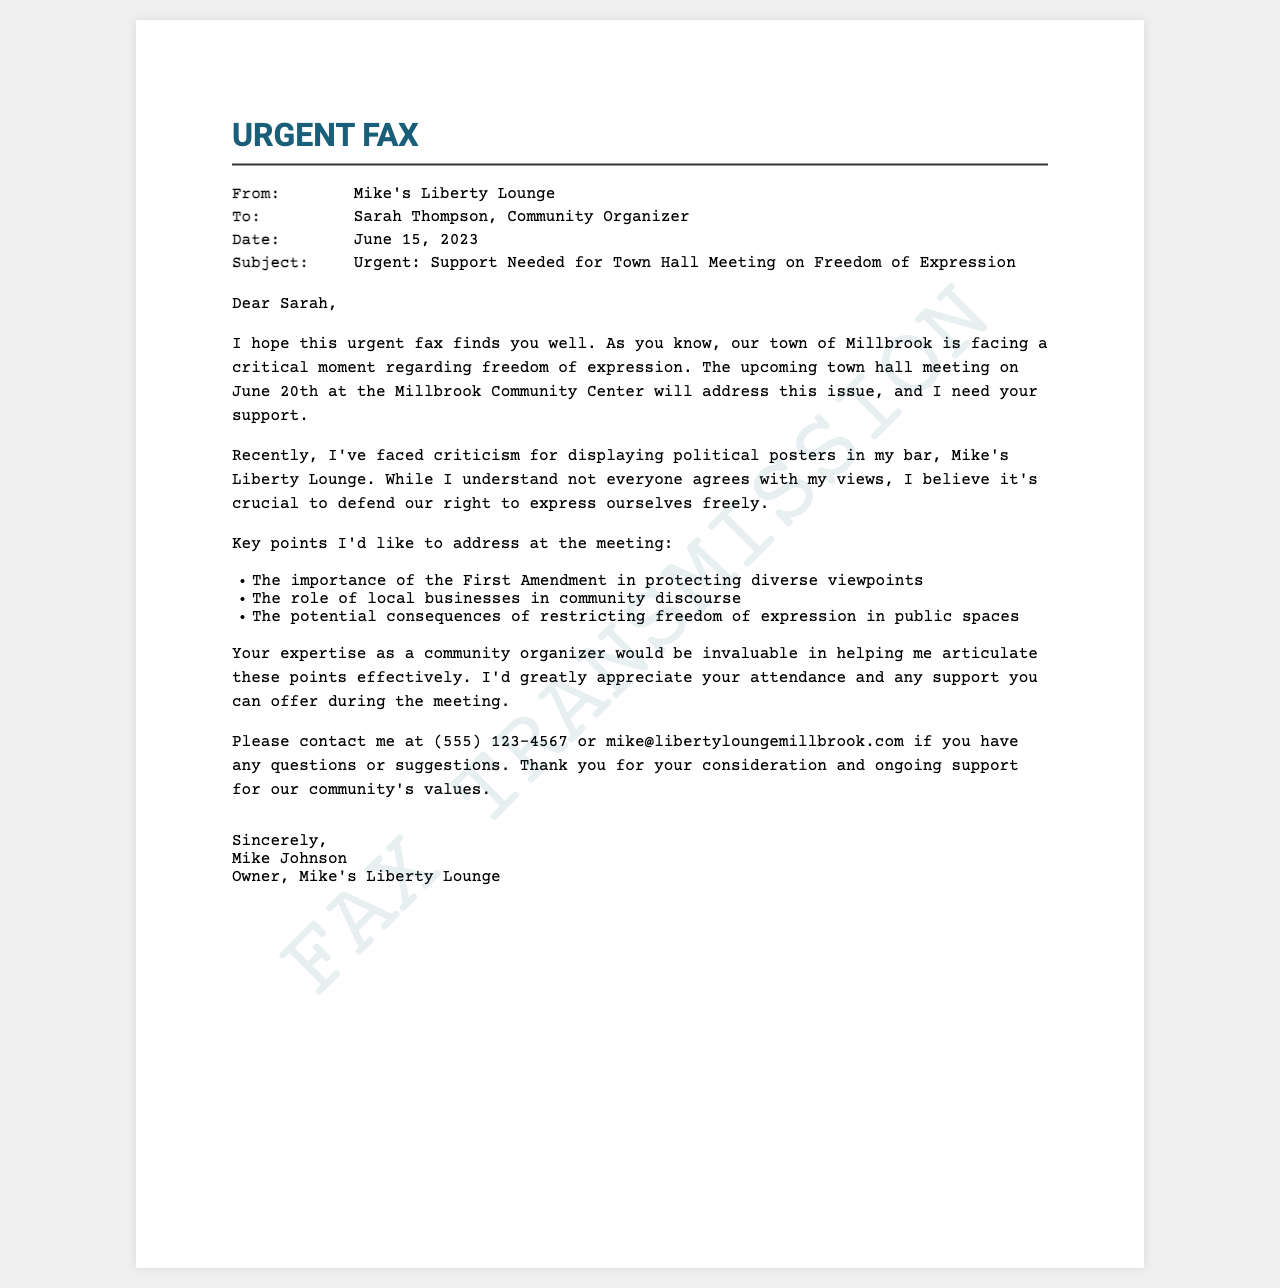What is the sender's name? The sender of the fax is identified as the owner of Mike's Liberty Lounge, which is Mike Johnson.
Answer: Mike Johnson What is the date of the town hall meeting? The fax mentions that the town hall meeting is scheduled for June 20th.
Answer: June 20th What topic will the meeting address? The subject of the meeting revolves around freedom of expression, as stated in the fax.
Answer: Freedom of expression Who is the recipient of the fax? The fax is addressed to Sarah Thompson, who is a community organizer.
Answer: Sarah Thompson What key point addresses the role of local businesses? The fax lists the role of local businesses in community discourse as one of the points for discussion at the meeting.
Answer: The role of local businesses in community discourse What is the contact phone number provided? The sender includes a contact number for further communication, which is (555) 123-4567.
Answer: (555) 123-4567 How many key points does the fax mention? The document lists three key points that the sender wishes to address at the meeting.
Answer: Three What is the purpose of this fax? The primary purpose of the fax is to request support for the town hall meeting.
Answer: Request support for the town hall meeting What is the sender’s email address? The email address provided for contact is mike@libertyloungemillbrook.com.
Answer: mike@libertyloungemillbrook.com 